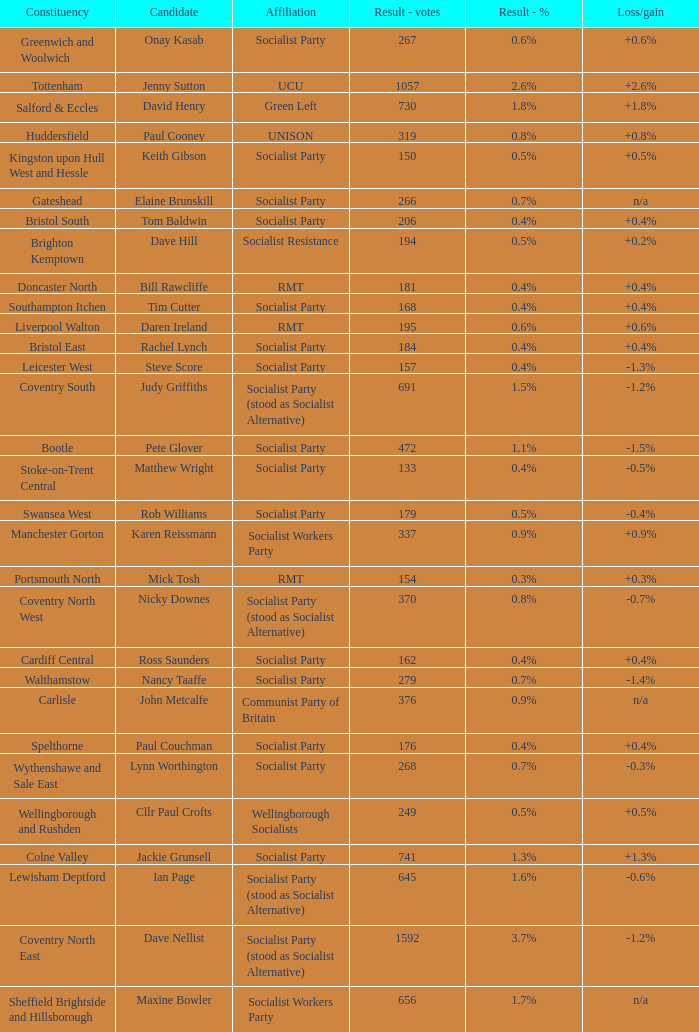What is every candidate for the Cardiff Central constituency? Ross Saunders. 